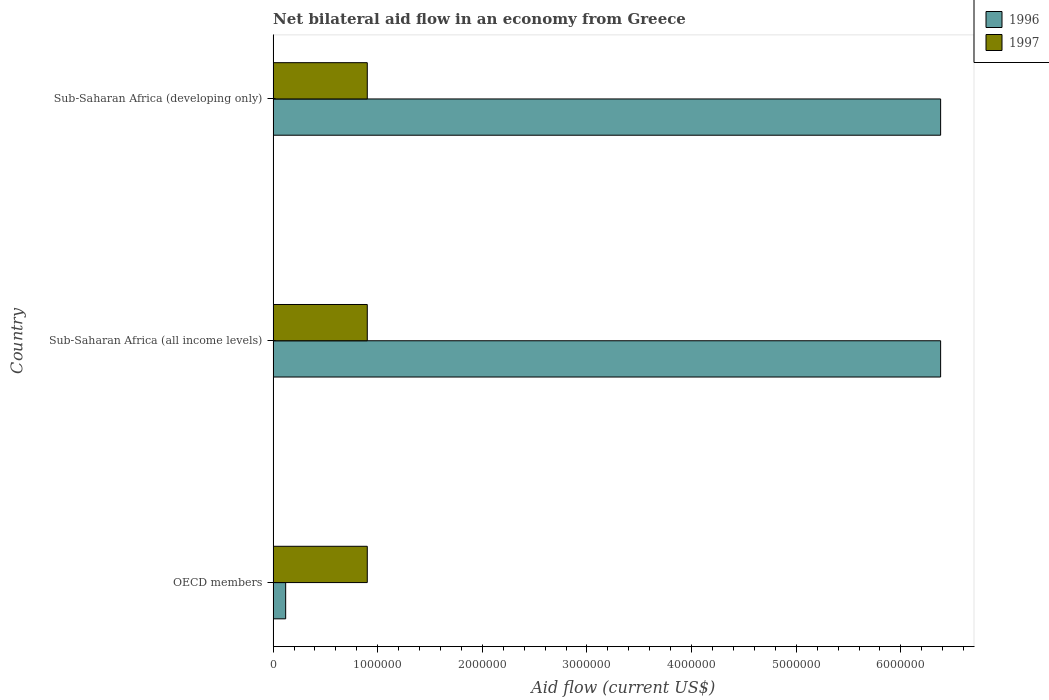How many groups of bars are there?
Provide a short and direct response. 3. Are the number of bars per tick equal to the number of legend labels?
Offer a very short reply. Yes. Are the number of bars on each tick of the Y-axis equal?
Make the answer very short. Yes. What is the label of the 1st group of bars from the top?
Provide a short and direct response. Sub-Saharan Africa (developing only). In how many cases, is the number of bars for a given country not equal to the number of legend labels?
Offer a very short reply. 0. What is the net bilateral aid flow in 1996 in Sub-Saharan Africa (all income levels)?
Your answer should be compact. 6.38e+06. Across all countries, what is the minimum net bilateral aid flow in 1997?
Your answer should be compact. 9.00e+05. In which country was the net bilateral aid flow in 1996 maximum?
Make the answer very short. Sub-Saharan Africa (all income levels). In which country was the net bilateral aid flow in 1996 minimum?
Give a very brief answer. OECD members. What is the total net bilateral aid flow in 1996 in the graph?
Your answer should be very brief. 1.29e+07. What is the difference between the net bilateral aid flow in 1996 in OECD members and that in Sub-Saharan Africa (all income levels)?
Keep it short and to the point. -6.26e+06. What is the difference between the net bilateral aid flow in 1997 in Sub-Saharan Africa (all income levels) and the net bilateral aid flow in 1996 in OECD members?
Provide a short and direct response. 7.80e+05. What is the average net bilateral aid flow in 1996 per country?
Offer a very short reply. 4.29e+06. What is the difference between the net bilateral aid flow in 1997 and net bilateral aid flow in 1996 in Sub-Saharan Africa (developing only)?
Keep it short and to the point. -5.48e+06. In how many countries, is the net bilateral aid flow in 1996 greater than 2800000 US$?
Your answer should be very brief. 2. What is the ratio of the net bilateral aid flow in 1996 in OECD members to that in Sub-Saharan Africa (developing only)?
Your answer should be very brief. 0.02. Is the net bilateral aid flow in 1997 in OECD members less than that in Sub-Saharan Africa (developing only)?
Keep it short and to the point. No. Is the difference between the net bilateral aid flow in 1997 in OECD members and Sub-Saharan Africa (all income levels) greater than the difference between the net bilateral aid flow in 1996 in OECD members and Sub-Saharan Africa (all income levels)?
Make the answer very short. Yes. What is the difference between the highest and the lowest net bilateral aid flow in 1996?
Your answer should be very brief. 6.26e+06. Is the sum of the net bilateral aid flow in 1997 in Sub-Saharan Africa (all income levels) and Sub-Saharan Africa (developing only) greater than the maximum net bilateral aid flow in 1996 across all countries?
Offer a very short reply. No. What does the 1st bar from the top in OECD members represents?
Make the answer very short. 1997. What does the 2nd bar from the bottom in Sub-Saharan Africa (developing only) represents?
Provide a short and direct response. 1997. How many bars are there?
Your answer should be very brief. 6. How many countries are there in the graph?
Your answer should be very brief. 3. What is the difference between two consecutive major ticks on the X-axis?
Provide a succinct answer. 1.00e+06. Are the values on the major ticks of X-axis written in scientific E-notation?
Provide a succinct answer. No. Does the graph contain any zero values?
Your answer should be very brief. No. Where does the legend appear in the graph?
Keep it short and to the point. Top right. How many legend labels are there?
Offer a very short reply. 2. What is the title of the graph?
Provide a short and direct response. Net bilateral aid flow in an economy from Greece. What is the label or title of the X-axis?
Your answer should be compact. Aid flow (current US$). What is the Aid flow (current US$) in 1996 in Sub-Saharan Africa (all income levels)?
Make the answer very short. 6.38e+06. What is the Aid flow (current US$) in 1996 in Sub-Saharan Africa (developing only)?
Your response must be concise. 6.38e+06. What is the Aid flow (current US$) in 1997 in Sub-Saharan Africa (developing only)?
Offer a terse response. 9.00e+05. Across all countries, what is the maximum Aid flow (current US$) of 1996?
Offer a terse response. 6.38e+06. Across all countries, what is the maximum Aid flow (current US$) of 1997?
Make the answer very short. 9.00e+05. Across all countries, what is the minimum Aid flow (current US$) of 1996?
Provide a short and direct response. 1.20e+05. What is the total Aid flow (current US$) of 1996 in the graph?
Offer a terse response. 1.29e+07. What is the total Aid flow (current US$) of 1997 in the graph?
Keep it short and to the point. 2.70e+06. What is the difference between the Aid flow (current US$) in 1996 in OECD members and that in Sub-Saharan Africa (all income levels)?
Keep it short and to the point. -6.26e+06. What is the difference between the Aid flow (current US$) in 1996 in OECD members and that in Sub-Saharan Africa (developing only)?
Offer a very short reply. -6.26e+06. What is the difference between the Aid flow (current US$) of 1996 in Sub-Saharan Africa (all income levels) and that in Sub-Saharan Africa (developing only)?
Your answer should be compact. 0. What is the difference between the Aid flow (current US$) of 1996 in OECD members and the Aid flow (current US$) of 1997 in Sub-Saharan Africa (all income levels)?
Your answer should be compact. -7.80e+05. What is the difference between the Aid flow (current US$) of 1996 in OECD members and the Aid flow (current US$) of 1997 in Sub-Saharan Africa (developing only)?
Give a very brief answer. -7.80e+05. What is the difference between the Aid flow (current US$) in 1996 in Sub-Saharan Africa (all income levels) and the Aid flow (current US$) in 1997 in Sub-Saharan Africa (developing only)?
Make the answer very short. 5.48e+06. What is the average Aid flow (current US$) in 1996 per country?
Your answer should be compact. 4.29e+06. What is the average Aid flow (current US$) of 1997 per country?
Your answer should be compact. 9.00e+05. What is the difference between the Aid flow (current US$) of 1996 and Aid flow (current US$) of 1997 in OECD members?
Your answer should be compact. -7.80e+05. What is the difference between the Aid flow (current US$) of 1996 and Aid flow (current US$) of 1997 in Sub-Saharan Africa (all income levels)?
Offer a very short reply. 5.48e+06. What is the difference between the Aid flow (current US$) of 1996 and Aid flow (current US$) of 1997 in Sub-Saharan Africa (developing only)?
Offer a terse response. 5.48e+06. What is the ratio of the Aid flow (current US$) of 1996 in OECD members to that in Sub-Saharan Africa (all income levels)?
Make the answer very short. 0.02. What is the ratio of the Aid flow (current US$) of 1996 in OECD members to that in Sub-Saharan Africa (developing only)?
Keep it short and to the point. 0.02. What is the ratio of the Aid flow (current US$) of 1997 in OECD members to that in Sub-Saharan Africa (developing only)?
Your response must be concise. 1. What is the ratio of the Aid flow (current US$) in 1996 in Sub-Saharan Africa (all income levels) to that in Sub-Saharan Africa (developing only)?
Offer a terse response. 1. What is the ratio of the Aid flow (current US$) of 1997 in Sub-Saharan Africa (all income levels) to that in Sub-Saharan Africa (developing only)?
Your answer should be compact. 1. What is the difference between the highest and the second highest Aid flow (current US$) in 1996?
Ensure brevity in your answer.  0. What is the difference between the highest and the lowest Aid flow (current US$) in 1996?
Ensure brevity in your answer.  6.26e+06. 